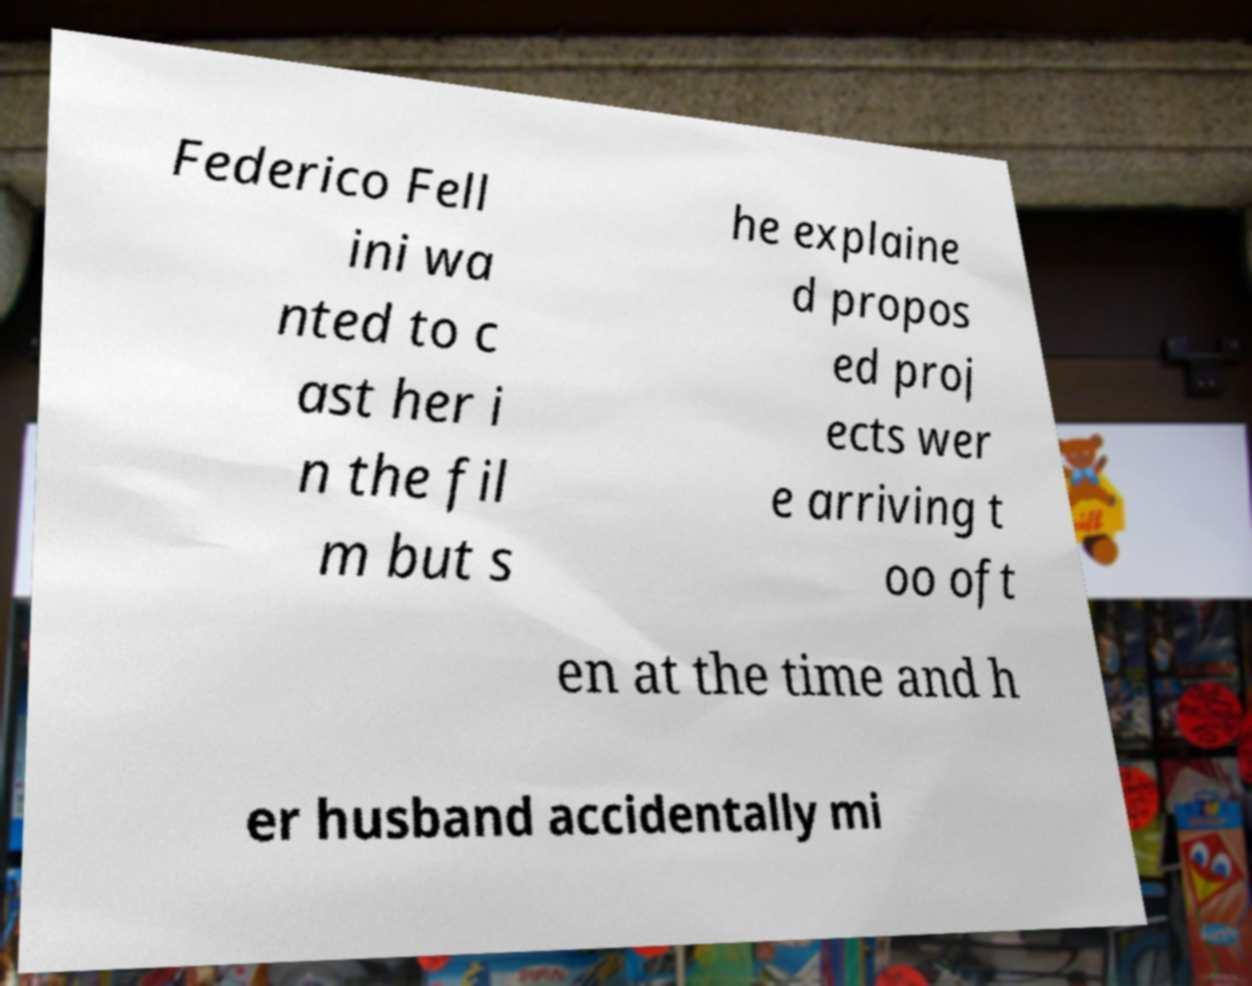What messages or text are displayed in this image? I need them in a readable, typed format. Federico Fell ini wa nted to c ast her i n the fil m but s he explaine d propos ed proj ects wer e arriving t oo oft en at the time and h er husband accidentally mi 